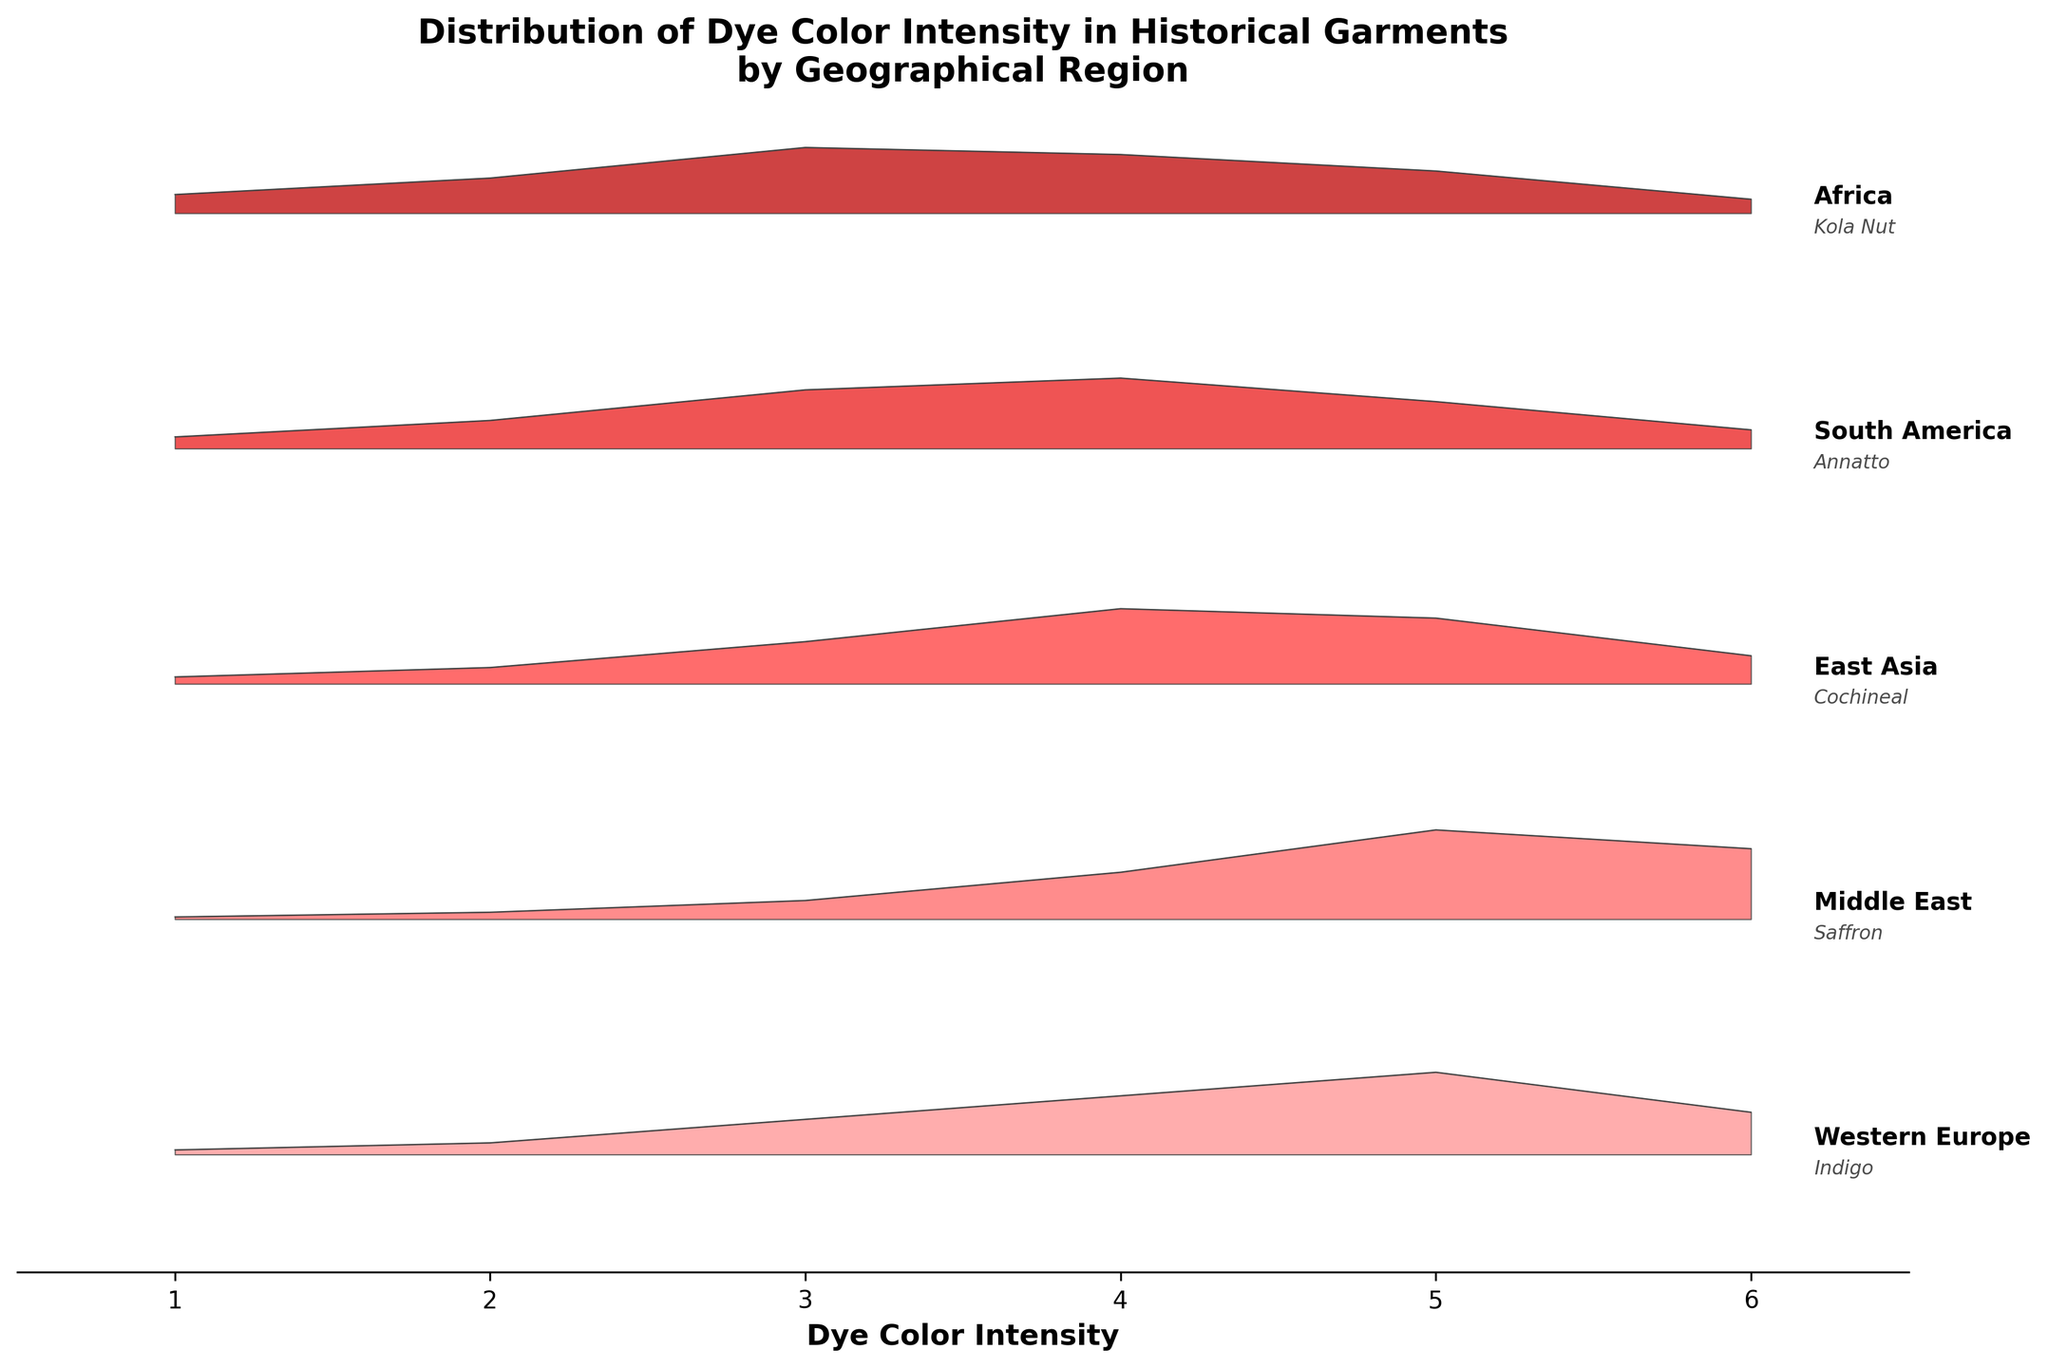What's the title of the figure? The title can be found at the top of the figure. It summarizes the main subject of the plot.
Answer: Distribution of Dye Color Intensity in Historical Garments by Geographical Region Which region has the highest frequency of dye color intensity 5? Review the plots for each region and identify the one with the highest frequency at intensity level 5.
Answer: Middle East How does the frequency of dye color intensity 6 compare between Western Europe and Africa? Look at the height of the ridgeline peaks at intensity 6 for both Western Europe and Africa. Compare these heights.
Answer: Western Europe has a higher frequency What's the range of the x-axis? The x-axis range is shown at the bottom of the figure, determining the spread of dye color intensity values.
Answer: 1 to 6 What is the most common dye color intensity in South America? Identify the intensity level with the highest peak in the South America section of the plot.
Answer: Intensity 4 Which region shows the most diverse distribution of dye color intensities? Look for the region with the widest spread and variation in peak heights across different intensities.
Answer: Africa At what intensity does East Asia show the maximum frequency, and what is that frequency? Identify the highest peak in the East Asia region and note its intensity and height.
Answer: Intensity 4, 0.32 How does the frequency of the highest intensity in South America compare to the highest intensity in Middle East? Identify the peaks with the highest frequency for each region and compare their heights.
Answer: South America is lower Which region exhibits a gradual increase in frequency with increasing dye color intensity up to a certain point and then starts decreasing? Look for a region where the peaks rise gradually and then fall after reaching a peak.
Answer: Western Europe What do the y-axis labels represent? Since there are no numerical labels on the y-axis, it likely represents categories or groupings rather than numeric values. In this context, it represents different geographical regions.
Answer: Different geographical regions 